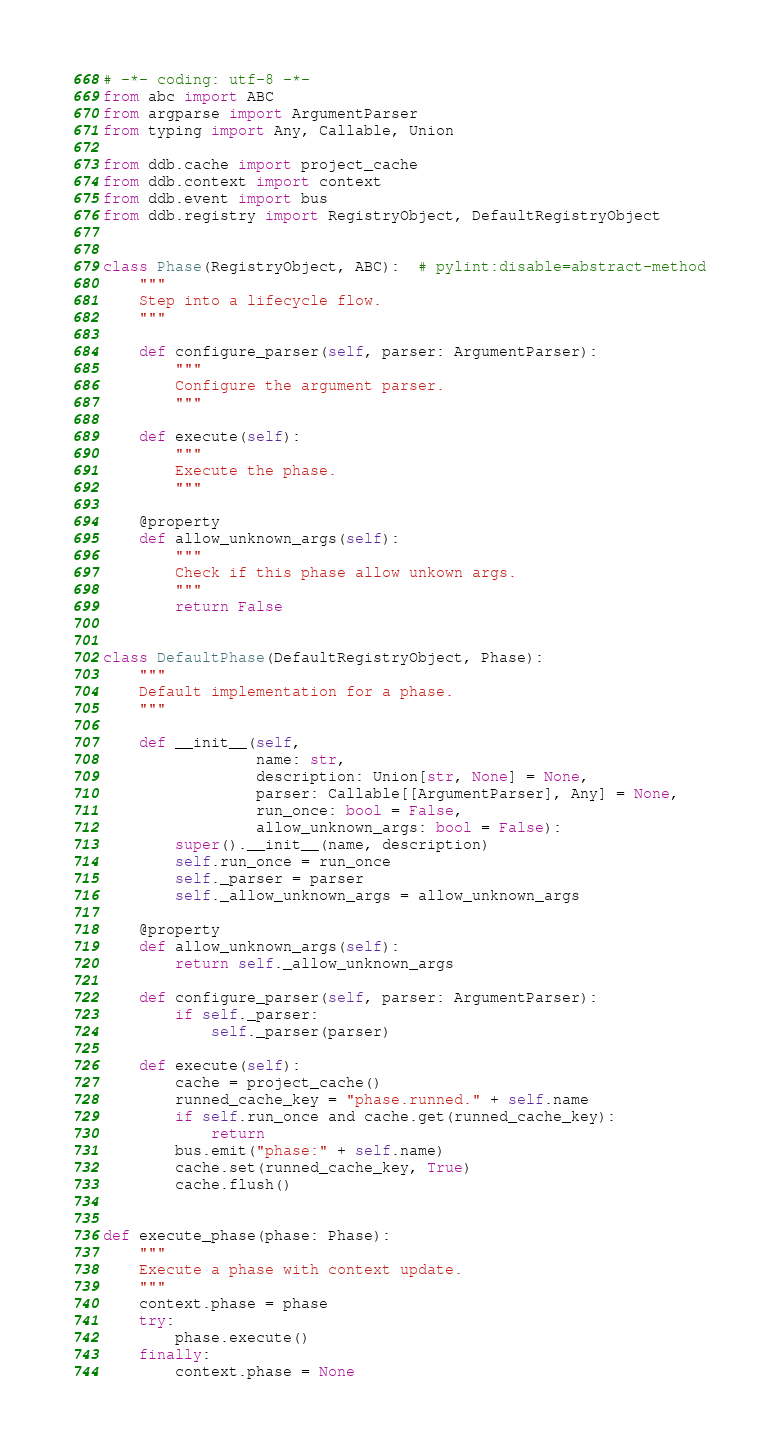Convert code to text. <code><loc_0><loc_0><loc_500><loc_500><_Python_># -*- coding: utf-8 -*-
from abc import ABC
from argparse import ArgumentParser
from typing import Any, Callable, Union

from ddb.cache import project_cache
from ddb.context import context
from ddb.event import bus
from ddb.registry import RegistryObject, DefaultRegistryObject


class Phase(RegistryObject, ABC):  # pylint:disable=abstract-method
    """
    Step into a lifecycle flow.
    """

    def configure_parser(self, parser: ArgumentParser):
        """
        Configure the argument parser.
        """

    def execute(self):
        """
        Execute the phase.
        """

    @property
    def allow_unknown_args(self):
        """
        Check if this phase allow unkown args.
        """
        return False


class DefaultPhase(DefaultRegistryObject, Phase):
    """
    Default implementation for a phase.
    """

    def __init__(self,
                 name: str,
                 description: Union[str, None] = None,
                 parser: Callable[[ArgumentParser], Any] = None,
                 run_once: bool = False,
                 allow_unknown_args: bool = False):
        super().__init__(name, description)
        self.run_once = run_once
        self._parser = parser
        self._allow_unknown_args = allow_unknown_args

    @property
    def allow_unknown_args(self):
        return self._allow_unknown_args

    def configure_parser(self, parser: ArgumentParser):
        if self._parser:
            self._parser(parser)

    def execute(self):
        cache = project_cache()
        runned_cache_key = "phase.runned." + self.name
        if self.run_once and cache.get(runned_cache_key):
            return
        bus.emit("phase:" + self.name)
        cache.set(runned_cache_key, True)
        cache.flush()


def execute_phase(phase: Phase):
    """
    Execute a phase with context update.
    """
    context.phase = phase
    try:
        phase.execute()
    finally:
        context.phase = None
</code> 